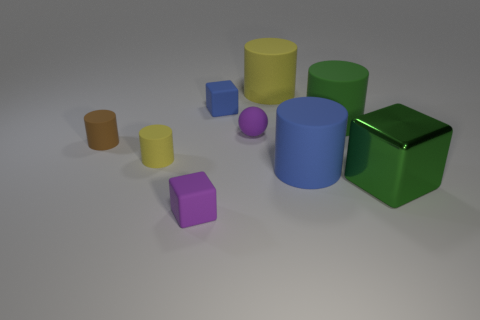Subtract all brown balls. How many yellow cylinders are left? 2 Subtract all blue cylinders. How many cylinders are left? 4 Subtract all green matte cylinders. How many cylinders are left? 4 Add 1 large yellow shiny cylinders. How many objects exist? 10 Subtract all green cylinders. Subtract all yellow cubes. How many cylinders are left? 4 Subtract all cylinders. How many objects are left? 4 Add 2 big blue rubber objects. How many big blue rubber objects exist? 3 Subtract 0 cyan cylinders. How many objects are left? 9 Subtract all tiny shiny spheres. Subtract all tiny brown matte cylinders. How many objects are left? 8 Add 5 green objects. How many green objects are left? 7 